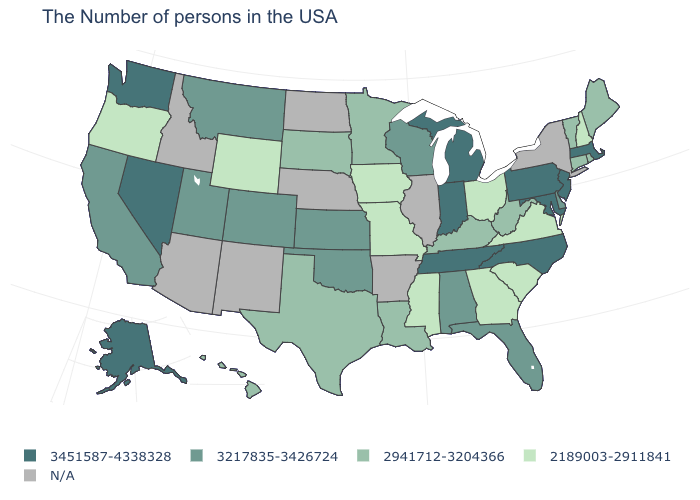Is the legend a continuous bar?
Answer briefly. No. Which states have the highest value in the USA?
Concise answer only. Massachusetts, New Jersey, Maryland, Pennsylvania, North Carolina, Michigan, Indiana, Tennessee, Nevada, Washington, Alaska. Is the legend a continuous bar?
Keep it brief. No. Does California have the highest value in the USA?
Concise answer only. No. What is the value of Utah?
Answer briefly. 3217835-3426724. What is the value of North Carolina?
Concise answer only. 3451587-4338328. Which states have the highest value in the USA?
Write a very short answer. Massachusetts, New Jersey, Maryland, Pennsylvania, North Carolina, Michigan, Indiana, Tennessee, Nevada, Washington, Alaska. What is the value of Washington?
Keep it brief. 3451587-4338328. What is the value of Pennsylvania?
Write a very short answer. 3451587-4338328. What is the value of Indiana?
Keep it brief. 3451587-4338328. What is the value of Michigan?
Be succinct. 3451587-4338328. What is the value of Colorado?
Keep it brief. 3217835-3426724. How many symbols are there in the legend?
Short answer required. 5. What is the highest value in the West ?
Write a very short answer. 3451587-4338328. 